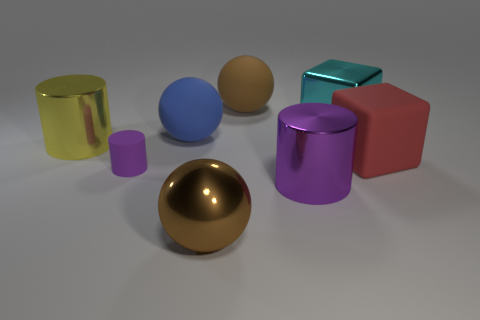What could be the function of these objects, or what setting do they belong to? These objects seem to serve an illustrative purpose rather than functional, as they resemble no real-world specific utility objects. Their various shapes and colors could imply this is a setting meant for studying lighting, materials, and rendering techniques in a 3D modeling environment. Each object could be used to demonstrate how different surfaces interact with light and shadow, such as the reflective metallic surfaces versus the opaque matte ones. 